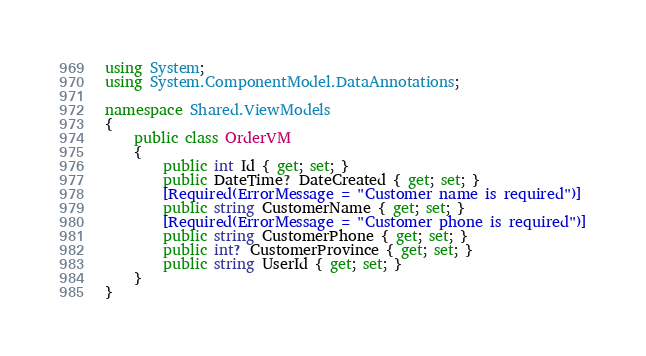Convert code to text. <code><loc_0><loc_0><loc_500><loc_500><_C#_>using System;
using System.ComponentModel.DataAnnotations;

namespace Shared.ViewModels
{
    public class OrderVM
    {
        public int Id { get; set; }
        public DateTime? DateCreated { get; set; }
        [Required(ErrorMessage = "Customer name is required")]
        public string CustomerName { get; set; }
        [Required(ErrorMessage = "Customer phone is required")]
        public string CustomerPhone { get; set; }
        public int? CustomerProvince { get; set; }
        public string UserId { get; set; }
    }
}</code> 